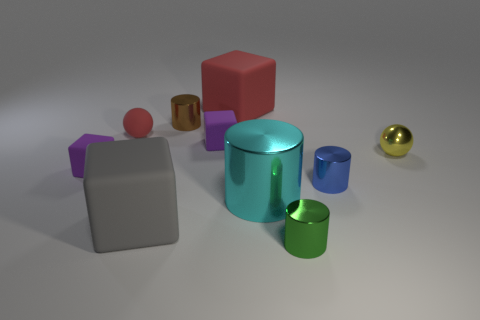Add 9 tiny green rubber cubes. How many tiny green rubber cubes exist? 9 Subtract all yellow spheres. How many spheres are left? 1 Subtract all gray blocks. How many blocks are left? 3 Subtract 0 red cylinders. How many objects are left? 10 Subtract all cylinders. How many objects are left? 6 Subtract 3 cylinders. How many cylinders are left? 1 Subtract all brown cylinders. Subtract all blue spheres. How many cylinders are left? 3 Subtract all green cubes. How many cyan cylinders are left? 1 Subtract all large cyan blocks. Subtract all gray blocks. How many objects are left? 9 Add 1 tiny green things. How many tiny green things are left? 2 